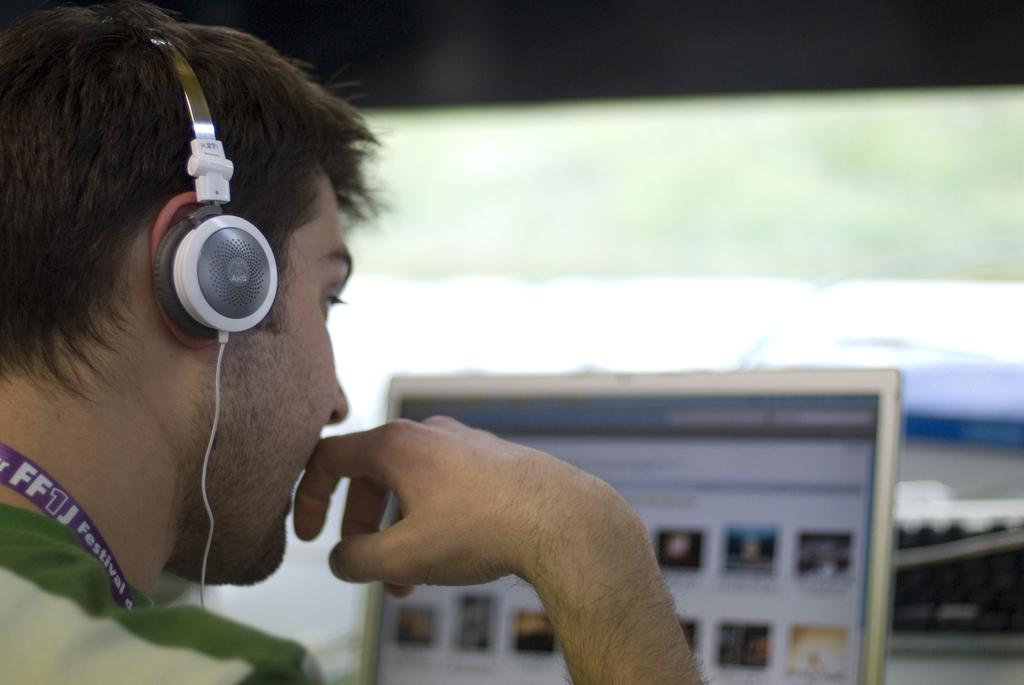What is located on the left side of the image? There is a person on the left side of the image. What is the person wearing? The person is wearing a headset. What device is the person using? The person is sitting in front of a laptop. What type of rose is the person holding in the image? There is no rose present in the image; the person is wearing a headset and sitting in front of a laptop. 